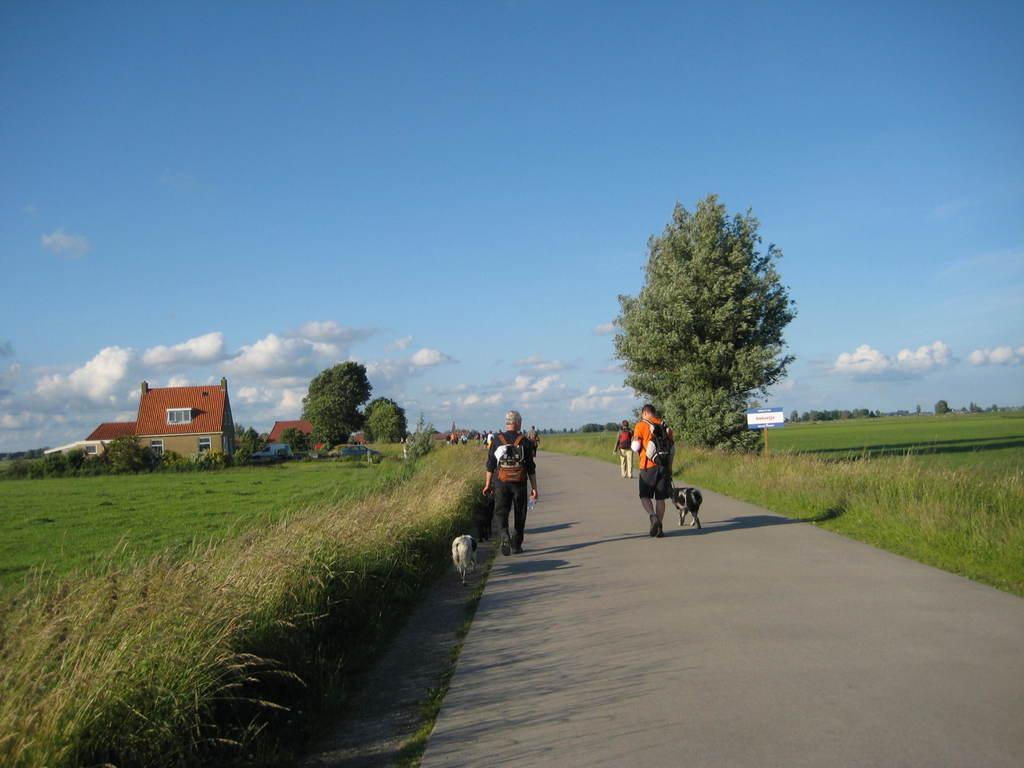Can you describe this image briefly? In this image I can see group of people walking on the road, in front the person is holding a dog and the dog is in black and white color. Background I can see trees and grass in green color, few houses in brown color and sky is in white and blue color. 